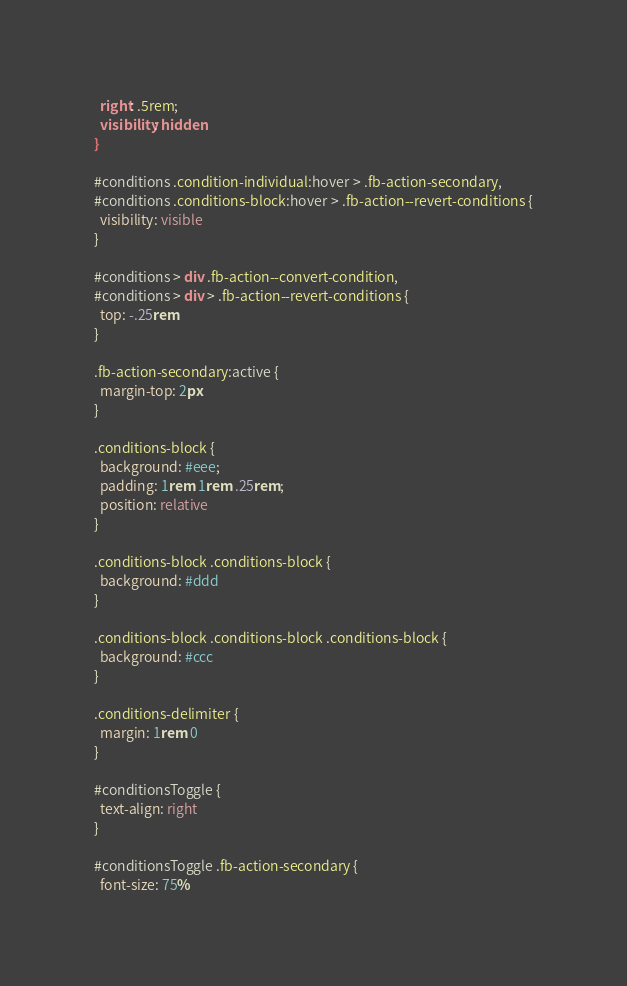Convert code to text. <code><loc_0><loc_0><loc_500><loc_500><_CSS_>  right: .5rem;
  visibility: hidden
}

#conditions .condition-individual:hover > .fb-action-secondary,
#conditions .conditions-block:hover > .fb-action--revert-conditions {
  visibility: visible
}

#conditions > div .fb-action--convert-condition,
#conditions > div > .fb-action--revert-conditions {
  top: -.25rem
}

.fb-action-secondary:active {
  margin-top: 2px
}

.conditions-block {
  background: #eee;
  padding: 1rem 1rem .25rem;
  position: relative
}

.conditions-block .conditions-block {
  background: #ddd
}

.conditions-block .conditions-block .conditions-block {
  background: #ccc
}

.conditions-delimiter {
  margin: 1rem 0
}

#conditionsToggle {
  text-align: right
}

#conditionsToggle .fb-action-secondary {
  font-size: 75%</code> 